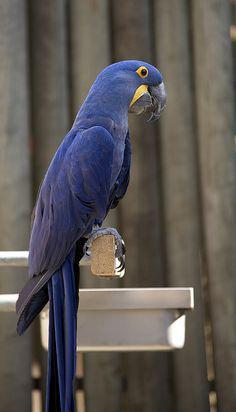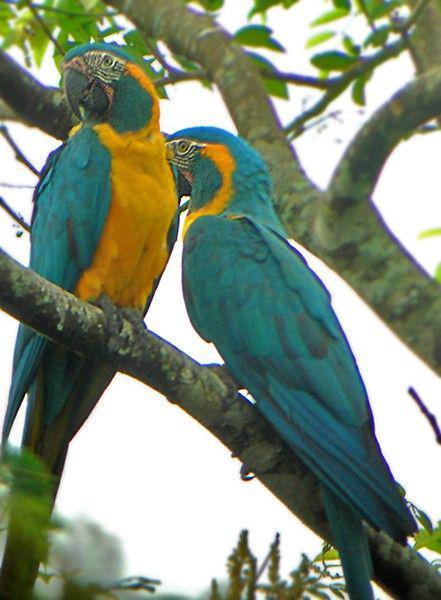The first image is the image on the left, the second image is the image on the right. For the images displayed, is the sentence "A total of three parrots are depicted in the images." factually correct? Answer yes or no. Yes. The first image is the image on the left, the second image is the image on the right. Analyze the images presented: Is the assertion "In one image, two teal colored parrots are sitting together on a tree branch." valid? Answer yes or no. Yes. 